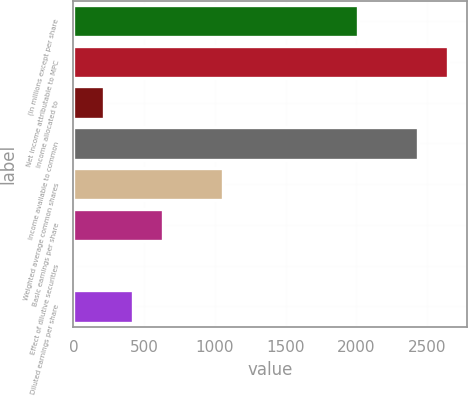<chart> <loc_0><loc_0><loc_500><loc_500><bar_chart><fcel>(In millions except per share<fcel>Net income attributable to MPC<fcel>Income allocated to<fcel>Income available to common<fcel>Weighted average common shares<fcel>Basic earnings per share<fcel>Effect of dilutive securities<fcel>Diluted earnings per share<nl><fcel>2013<fcel>2646<fcel>213<fcel>2435<fcel>1057<fcel>635<fcel>2<fcel>424<nl></chart> 